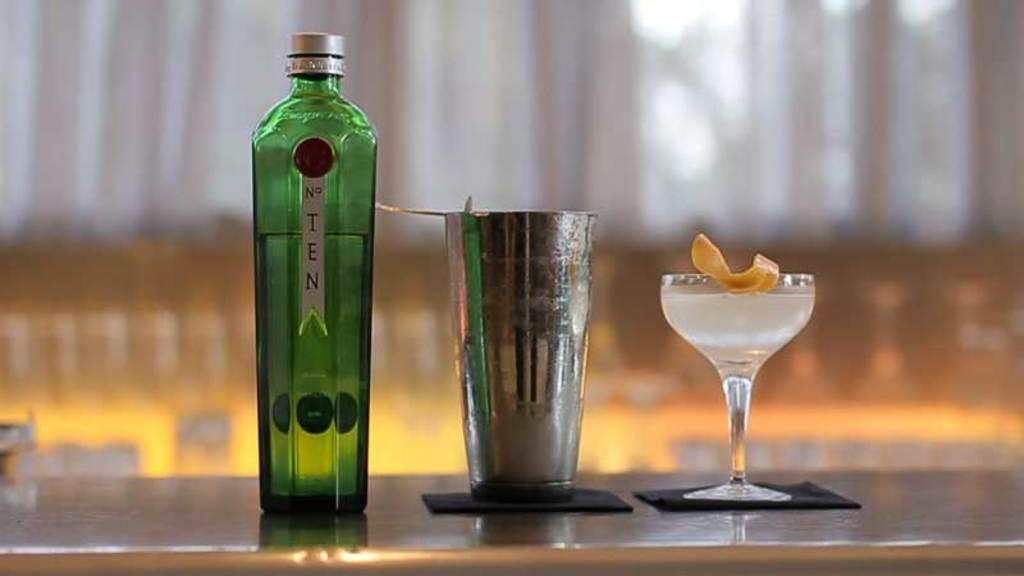<image>
Describe the image concisely. A bottle of No. Ten gin is on a counter along with a shaker and a filled martini glass. 